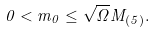<formula> <loc_0><loc_0><loc_500><loc_500>0 < m _ { 0 } \leq \sqrt { \Omega } M _ { ( 5 ) } .</formula> 